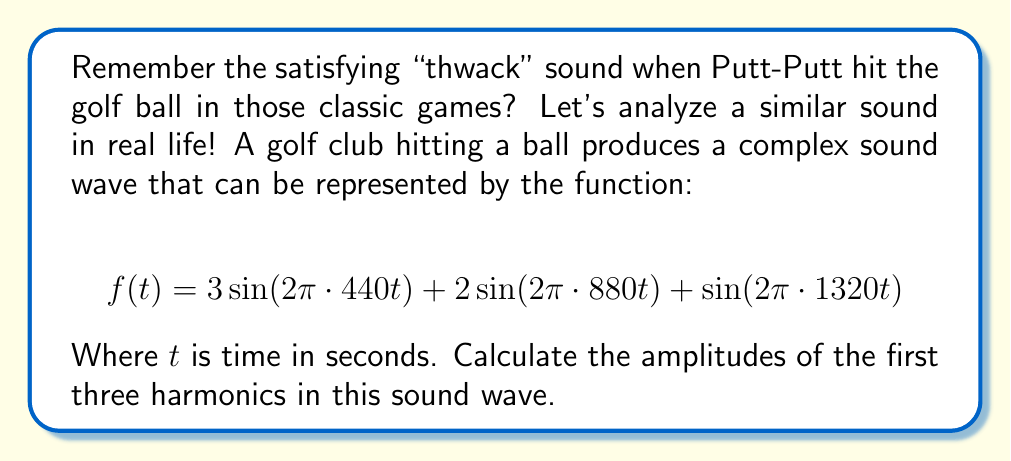Show me your answer to this math problem. To find the harmonics in this sound wave, we need to analyze the given function:

$$f(t) = 3\sin(2\pi \cdot 440t) + 2\sin(2\pi \cdot 880t) + \sin(2\pi \cdot 1320t)$$

This function is already expressed as a sum of sine waves, which makes our task easier. Let's break it down:

1. The general form of a sine wave is $A\sin(2\pi ft)$, where $A$ is the amplitude and $f$ is the frequency.

2. In our function, we have three sine waves:
   a) $3\sin(2\pi \cdot 440t)$
   b) $2\sin(2\pi \cdot 880t)$
   c) $\sin(2\pi \cdot 1320t)$

3. The fundamental frequency (first harmonic) is the lowest frequency in the wave, which is 440 Hz.

4. The second harmonic is twice the fundamental frequency: $880 \text{ Hz} = 2 \cdot 440 \text{ Hz}$

5. The third harmonic is three times the fundamental frequency: $1320 \text{ Hz} = 3 \cdot 440 \text{ Hz}$

6. The amplitudes of these harmonics are the coefficients of the sine terms:
   - First harmonic (440 Hz): amplitude = 3
   - Second harmonic (880 Hz): amplitude = 2
   - Third harmonic (1320 Hz): amplitude = 1

Therefore, the amplitudes of the first three harmonics are 3, 2, and 1 respectively.
Answer: The amplitudes of the first three harmonics are:
1st harmonic: 3
2nd harmonic: 2
3rd harmonic: 1 